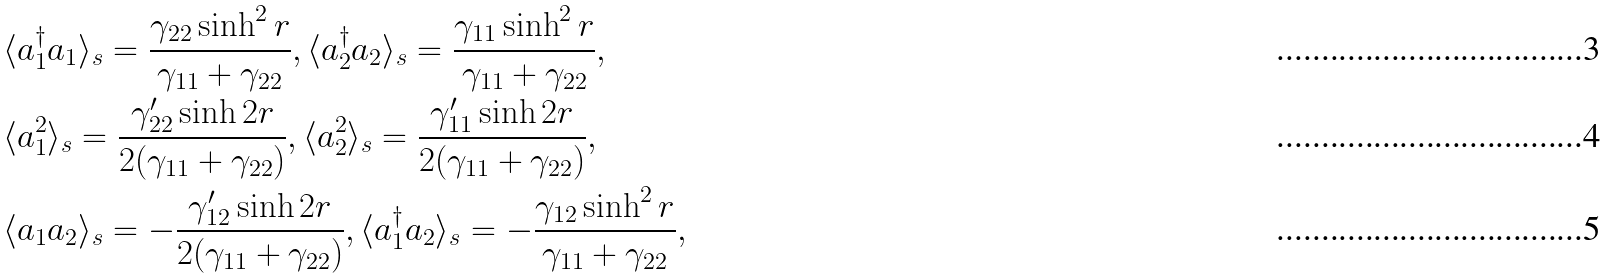Convert formula to latex. <formula><loc_0><loc_0><loc_500><loc_500>& \langle a _ { 1 } ^ { \dag } a _ { 1 } \rangle _ { s } = \frac { \gamma _ { 2 2 } \sinh ^ { 2 } r } { \gamma _ { 1 1 } + \gamma _ { 2 2 } } , \langle a _ { 2 } ^ { \dag } a _ { 2 } \rangle _ { s } = \frac { \gamma _ { 1 1 } \sinh ^ { 2 } r } { \gamma _ { 1 1 } + \gamma _ { 2 2 } } , \\ & \langle a _ { 1 } ^ { 2 } \rangle _ { s } = \frac { \gamma _ { 2 2 } ^ { \prime } \sinh 2 r } { 2 ( \gamma _ { 1 1 } + \gamma _ { 2 2 } ) } , \langle a _ { 2 } ^ { 2 } \rangle _ { s } = \frac { \gamma _ { 1 1 } ^ { \prime } \sinh 2 r } { 2 ( \gamma _ { 1 1 } + \gamma _ { 2 2 } ) } , \\ & \langle a _ { 1 } a _ { 2 } \rangle _ { s } = - \frac { \gamma _ { 1 2 } ^ { \prime } \sinh 2 r } { 2 ( \gamma _ { 1 1 } + \gamma _ { 2 2 } ) } , \langle a _ { 1 } ^ { \dag } a _ { 2 } \rangle _ { s } = - \frac { \gamma _ { 1 2 } \sinh ^ { 2 } r } { \gamma _ { 1 1 } + \gamma _ { 2 2 } } ,</formula> 